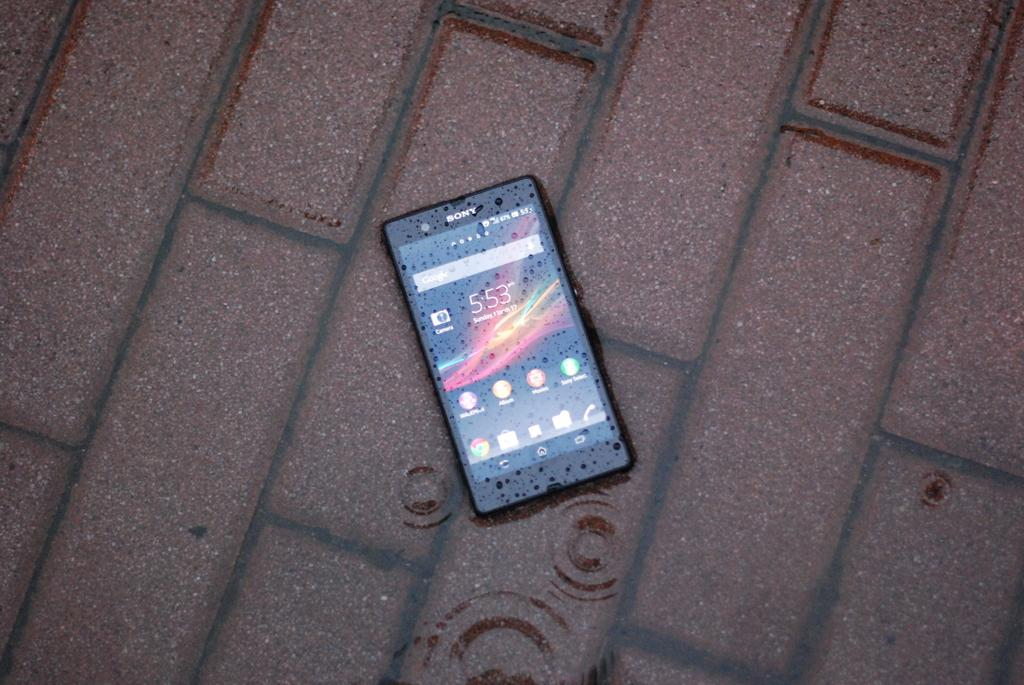<image>
Render a clear and concise summary of the photo. A cellphone at 5:53 on a brick walkway. 